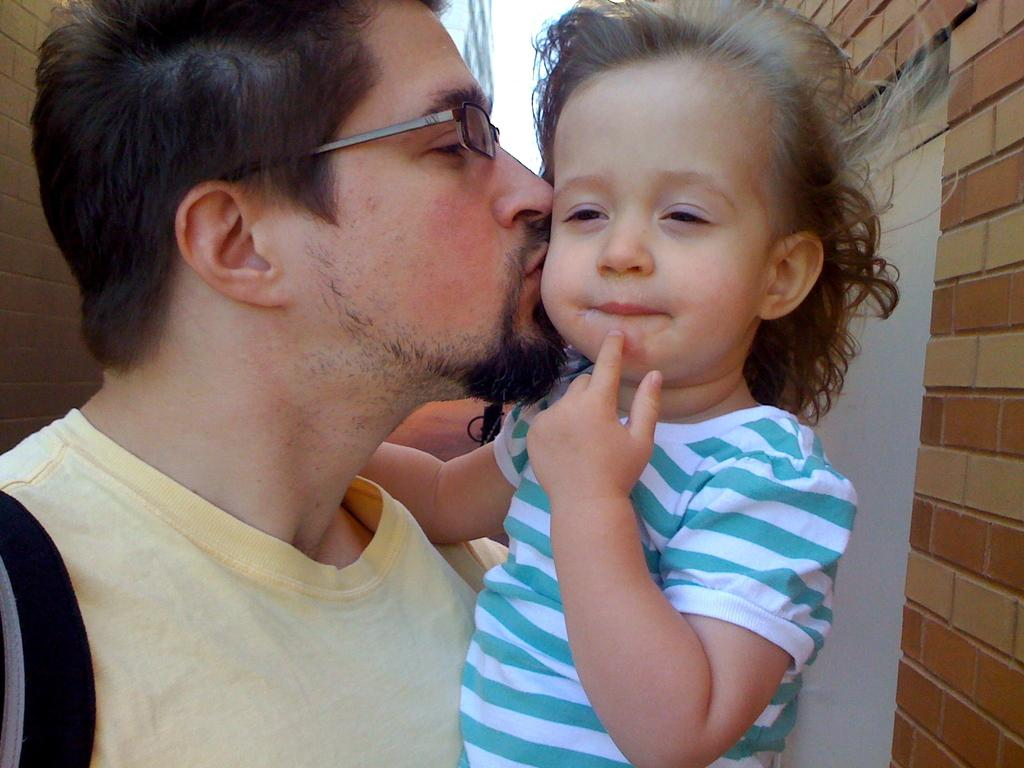Who is in the image? There is a person in the image. What is the person doing? The person is kissing a kid. What can be seen on the sides of the image? There are walls on both the left and right sides of the image. What is the aftermath of the fight in the image? There is no fight present in the image, so there is no aftermath to discuss. 